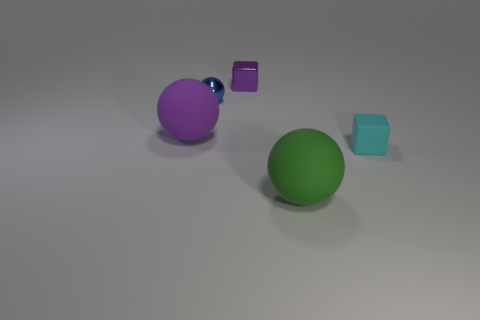Add 1 tiny blue balls. How many objects exist? 6 Subtract all cubes. How many objects are left? 3 Add 2 tiny things. How many tiny things are left? 5 Add 2 tiny metallic cubes. How many tiny metallic cubes exist? 3 Subtract 1 purple blocks. How many objects are left? 4 Subtract all small yellow cubes. Subtract all tiny blue metallic spheres. How many objects are left? 4 